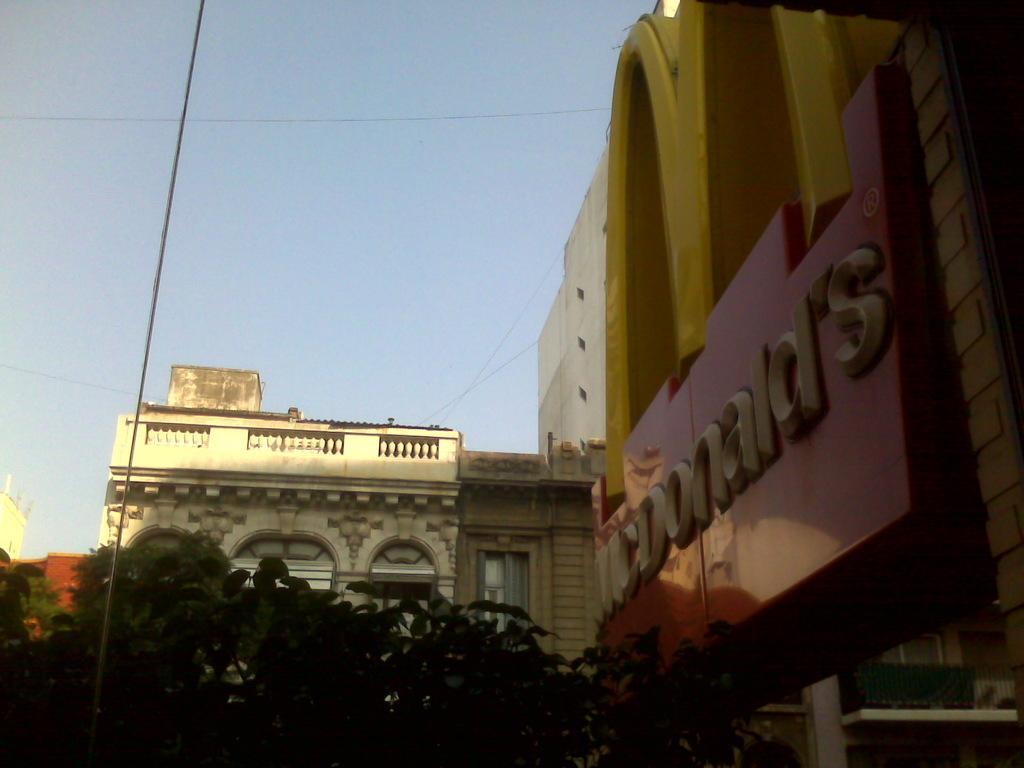How would you summarize this image in a sentence or two? In this image I see the buildings and I see something is written over here and I see the leaves and I see the wires. In the background I see the sky. 